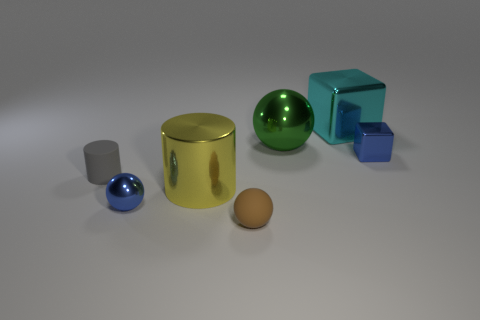There is a tiny blue object that is to the left of the blue shiny object that is on the right side of the large object in front of the small gray rubber thing; what is its material?
Your answer should be very brief. Metal. What material is the tiny blue thing that is behind the big object on the left side of the big green object?
Offer a terse response. Metal. There is another object that is the same shape as the cyan thing; what material is it?
Make the answer very short. Metal. There is a object that is both on the left side of the blue metal block and on the right side of the large metallic sphere; how big is it?
Make the answer very short. Large. Is there any other thing of the same color as the tiny rubber ball?
Keep it short and to the point. No. There is a rubber thing that is behind the big metallic thing on the left side of the small matte ball; how big is it?
Offer a very short reply. Small. The sphere that is both in front of the big yellow cylinder and on the right side of the blue metallic sphere is what color?
Offer a very short reply. Brown. What number of other things are there of the same size as the shiny cylinder?
Your answer should be very brief. 2. Does the gray rubber object have the same size as the metallic cylinder to the left of the brown rubber ball?
Provide a short and direct response. No. What color is the other ball that is the same size as the rubber ball?
Keep it short and to the point. Blue. 